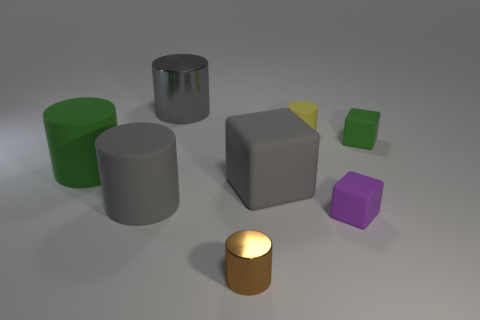Subtract all big gray cubes. How many cubes are left? 2 Add 1 purple blocks. How many objects exist? 9 Subtract all yellow cylinders. How many cylinders are left? 4 Subtract 1 cubes. How many cubes are left? 2 Subtract all cylinders. How many objects are left? 3 Subtract all purple cubes. Subtract all yellow cylinders. How many cubes are left? 2 Subtract all gray blocks. How many gray cylinders are left? 2 Subtract all big green rubber things. Subtract all large blocks. How many objects are left? 6 Add 7 tiny yellow objects. How many tiny yellow objects are left? 8 Add 6 green cylinders. How many green cylinders exist? 7 